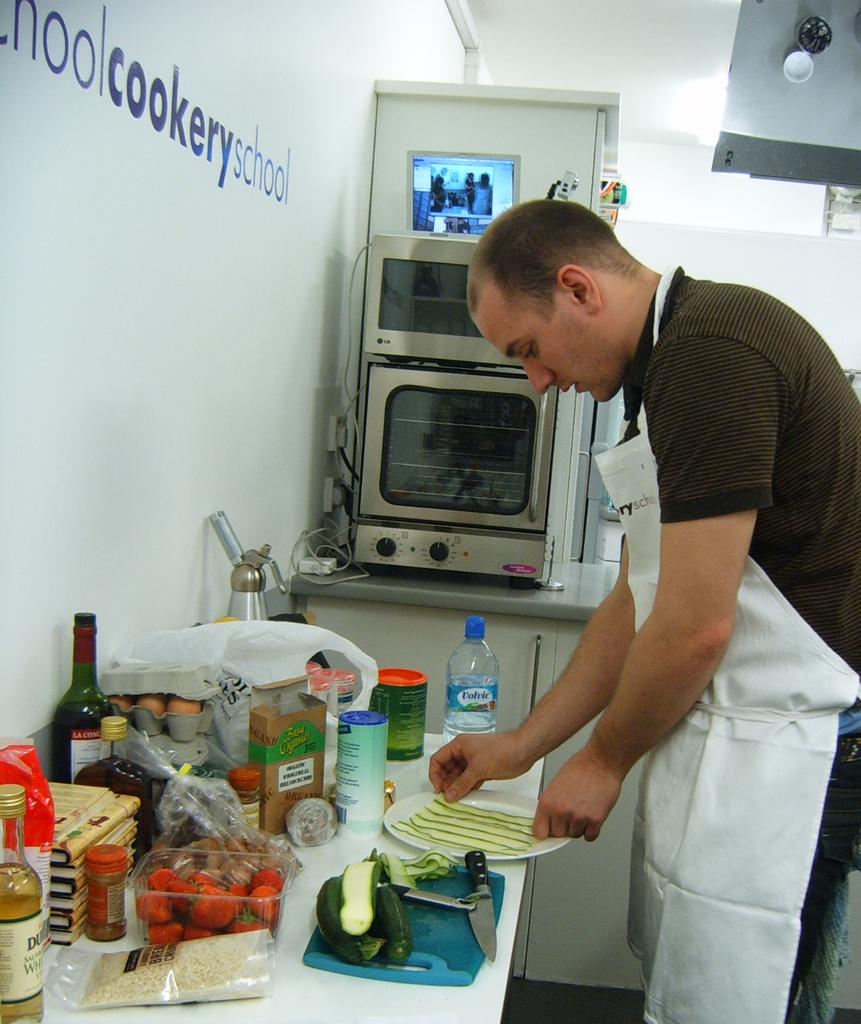What kind of school is this?
Give a very brief answer. Cookery. Is this a kitchen?
Give a very brief answer. Yes. 